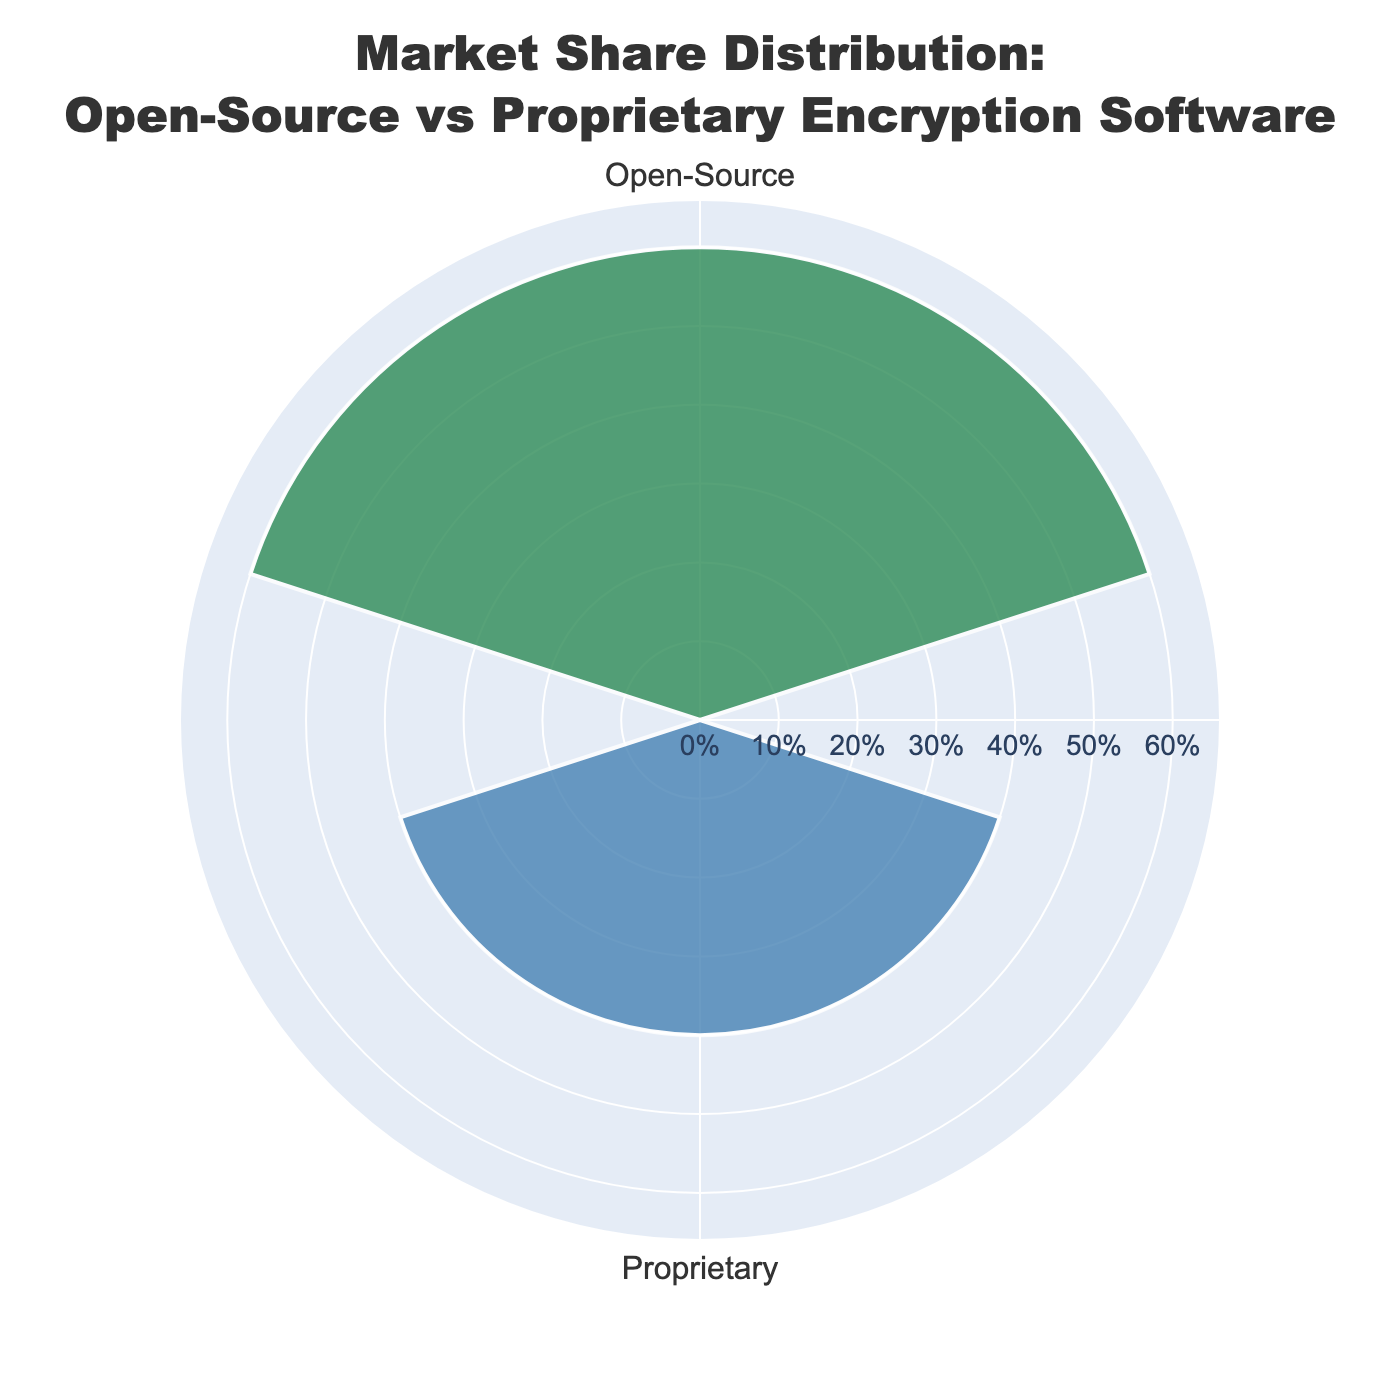What is the title of the chart? The title is located at the top center of the chart and reads "Market Share Distribution: Open-Source vs Proprietary Encryption Software".
Answer: Market Share Distribution: Open-Source vs Proprietary Encryption Software How many groups/categories are shown in the chart? The chart displays two distinct categories labeled as "Open-Source" and "Proprietary".
Answer: 2 Which category has a higher market share percentage? The "Open-Source" group has segments with market shares of 25%, 20%, and 15% which sum up to 60%, while the "Proprietary" group has segments with market shares of 20%, 10%, and 10% which sum up to 40%. Since 60% > 40%, "Open-Source" has a higher market share.
Answer: Open-Source What is the combined market share percentage of Open-Source encryption software? Adding up the segments: OpenSSL (25%), GnuPG (20%), and Veracrypt (15%) gives a total of 60% for Open-Source encryption software.
Answer: 60% What is the total market share percentage represented by Proprietary encryption software? Adding BitLocker (20%), Symantec Endpoint Encryption (10%), and Trend Micro Endpoint Encryption (10%) yields a total of 40% for Proprietary encryption software.
Answer: 40% Is there an equal distribution of market shares within each category? Comparing individual percentages within categories: Open-Source has 25%, 20%, 15% and Proprietary has 20%, 10%, 10%. These are not equal within each category.
Answer: No Which category has the smallest market share representation for any single software? The "Proprietary" category has smaller market shares of 10% for both Symantec Endpoint Encryption and Trend Micro Endpoint Encryption.
Answer: Proprietary By how much does the total market share of Open-Source software exceed that of Proprietary software? Subtract the total market share of Proprietary software (40%) from the total market share of Open-Source software (60%): 60% - 40% = 20%.
Answer: 20% What is the average market share percentage for software in the Proprietary category? Sum the market shares of proprietary software (20% + 10% + 10% = 40%) and divide by the number of software (3): 40% / 3 ≈ 13.33%.
Answer: 13.33% How is the market share information visually represented in the rose chart? Market share percentages are represented by the lengths (or radii) of the bars extending from the center, differentiated by color, with annotations indicating values.
Answer: By bar lengths and colors 